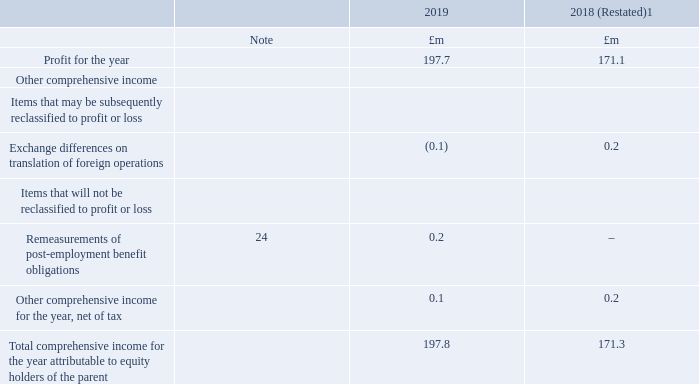Consolidated statement of comprehensive income
For the year ended 31 March 2019
1 The Group has adopted IFRS 9 ‘Financial Instruments’, IFRS 15 ‘Revenue from Contracts with Customers’, and IFRS 16 ‘Leases’ from 1 April 2018. The year ended 31 March 2018 has been restated for IFRS 16 which was implemented using the fully retrospective method. For further information on the impact of the change in accounting policies, see note 2 of these consolidated financial statements.
Which IFRS standard(s) did the Group adopt? Ifrs 9 ‘financial instruments’, ifrs 15 ‘revenue from contracts with customers’, and ifrs 16 ‘leases’ from 1 april 2018. What have the values in the 2018 column been restated for? For ifrs 16 which was implemented using the fully retrospective method. In which years was Profit for the year calculated in the Consolidated statement of comprehensive income? 2019, 2018. In which year was Profit for the year larger? 197.7>171.1
Answer: 2019. What was the change in profit for the year in 2019 from 2018?
Answer scale should be: million. 197.7-171.1
Answer: 26.6. What was the percentage change in profit for the year in 2019 from 2018?
Answer scale should be: percent. (197.7-171.1)/171.1
Answer: 15.55. 